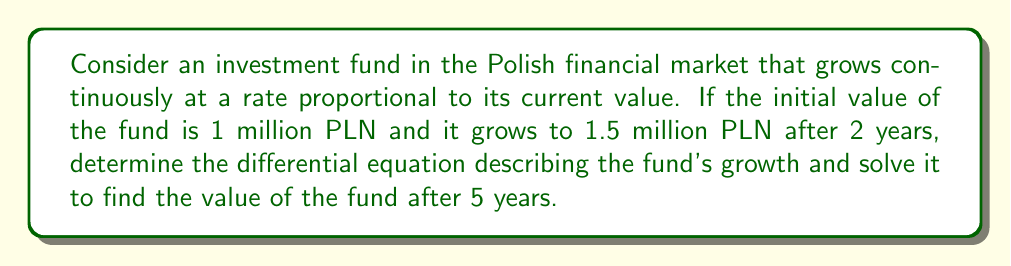Help me with this question. Let's approach this step-by-step:

1) Let $P(t)$ be the value of the fund at time $t$ (in years). The growth rate is proportional to the current value, so we can write the differential equation:

   $$\frac{dP}{dt} = kP$$

   where $k$ is the growth rate constant.

2) We're given two points:
   At $t=0$, $P(0) = 1$ million PLN
   At $t=2$, $P(2) = 1.5$ million PLN

3) The general solution to this differential equation is:

   $$P(t) = Ce^{kt}$$

   where $C$ is a constant.

4) Using the initial condition, we can find $C$:
   $P(0) = Ce^{k(0)} = C = 1$

5) So our solution is:
   $$P(t) = e^{kt}$$

6) Now we can use the second point to find $k$:
   $$1.5 = e^{2k}$$
   $$\ln(1.5) = 2k$$
   $$k = \frac{\ln(1.5)}{2} \approx 0.2027$$

7) Therefore, our complete solution is:
   $$P(t) = e^{0.2027t}$$

8) To find the value after 5 years, we simply plug in $t=5$:
   $$P(5) = e^{0.2027(5)} \approx 2.7583$$
Answer: The differential equation describing the fund's growth is $\frac{dP}{dt} = 0.2027P$, and the value of the fund after 5 years will be approximately 2.7583 million PLN. 